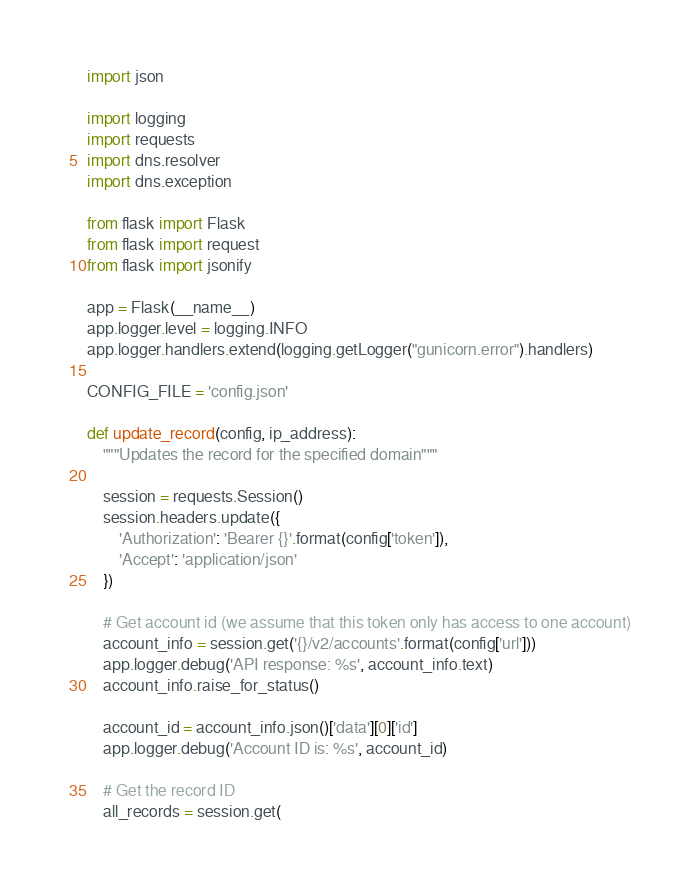<code> <loc_0><loc_0><loc_500><loc_500><_Python_>import json

import logging
import requests
import dns.resolver
import dns.exception

from flask import Flask
from flask import request
from flask import jsonify

app = Flask(__name__)
app.logger.level = logging.INFO
app.logger.handlers.extend(logging.getLogger("gunicorn.error").handlers)

CONFIG_FILE = 'config.json'

def update_record(config, ip_address):
    """Updates the record for the specified domain"""

    session = requests.Session()
    session.headers.update({
        'Authorization': 'Bearer {}'.format(config['token']),
        'Accept': 'application/json'
    })

    # Get account id (we assume that this token only has access to one account)
    account_info = session.get('{}/v2/accounts'.format(config['url']))
    app.logger.debug('API response: %s', account_info.text)
    account_info.raise_for_status()

    account_id = account_info.json()['data'][0]['id']
    app.logger.debug('Account ID is: %s', account_id)

    # Get the record ID
    all_records = session.get(</code> 